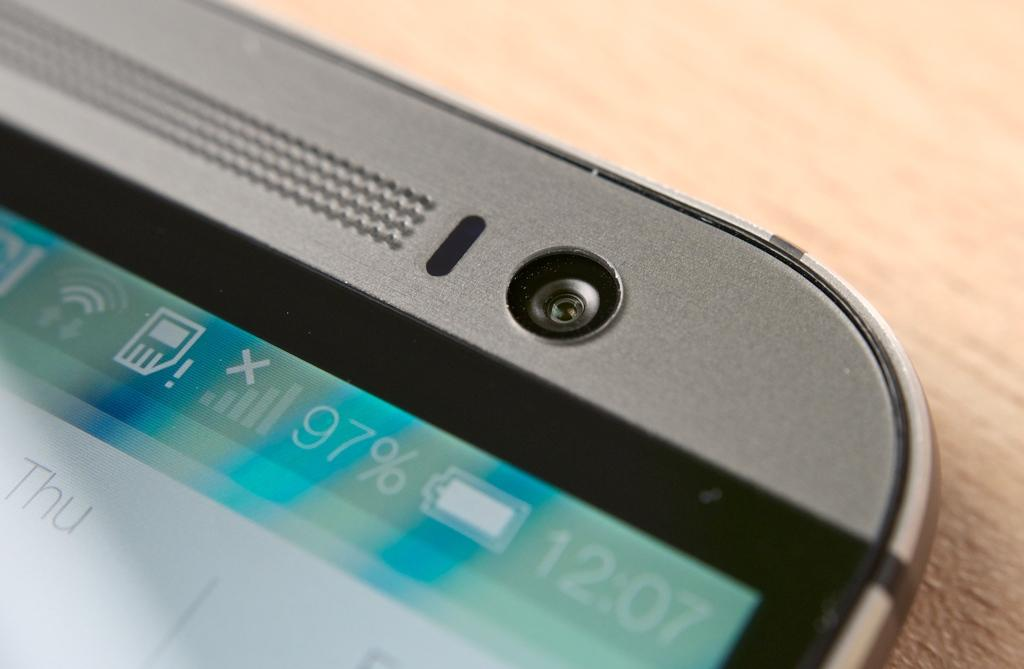<image>
Give a short and clear explanation of the subsequent image. A closeup of a phone shows the phone's battery is at 97%. 